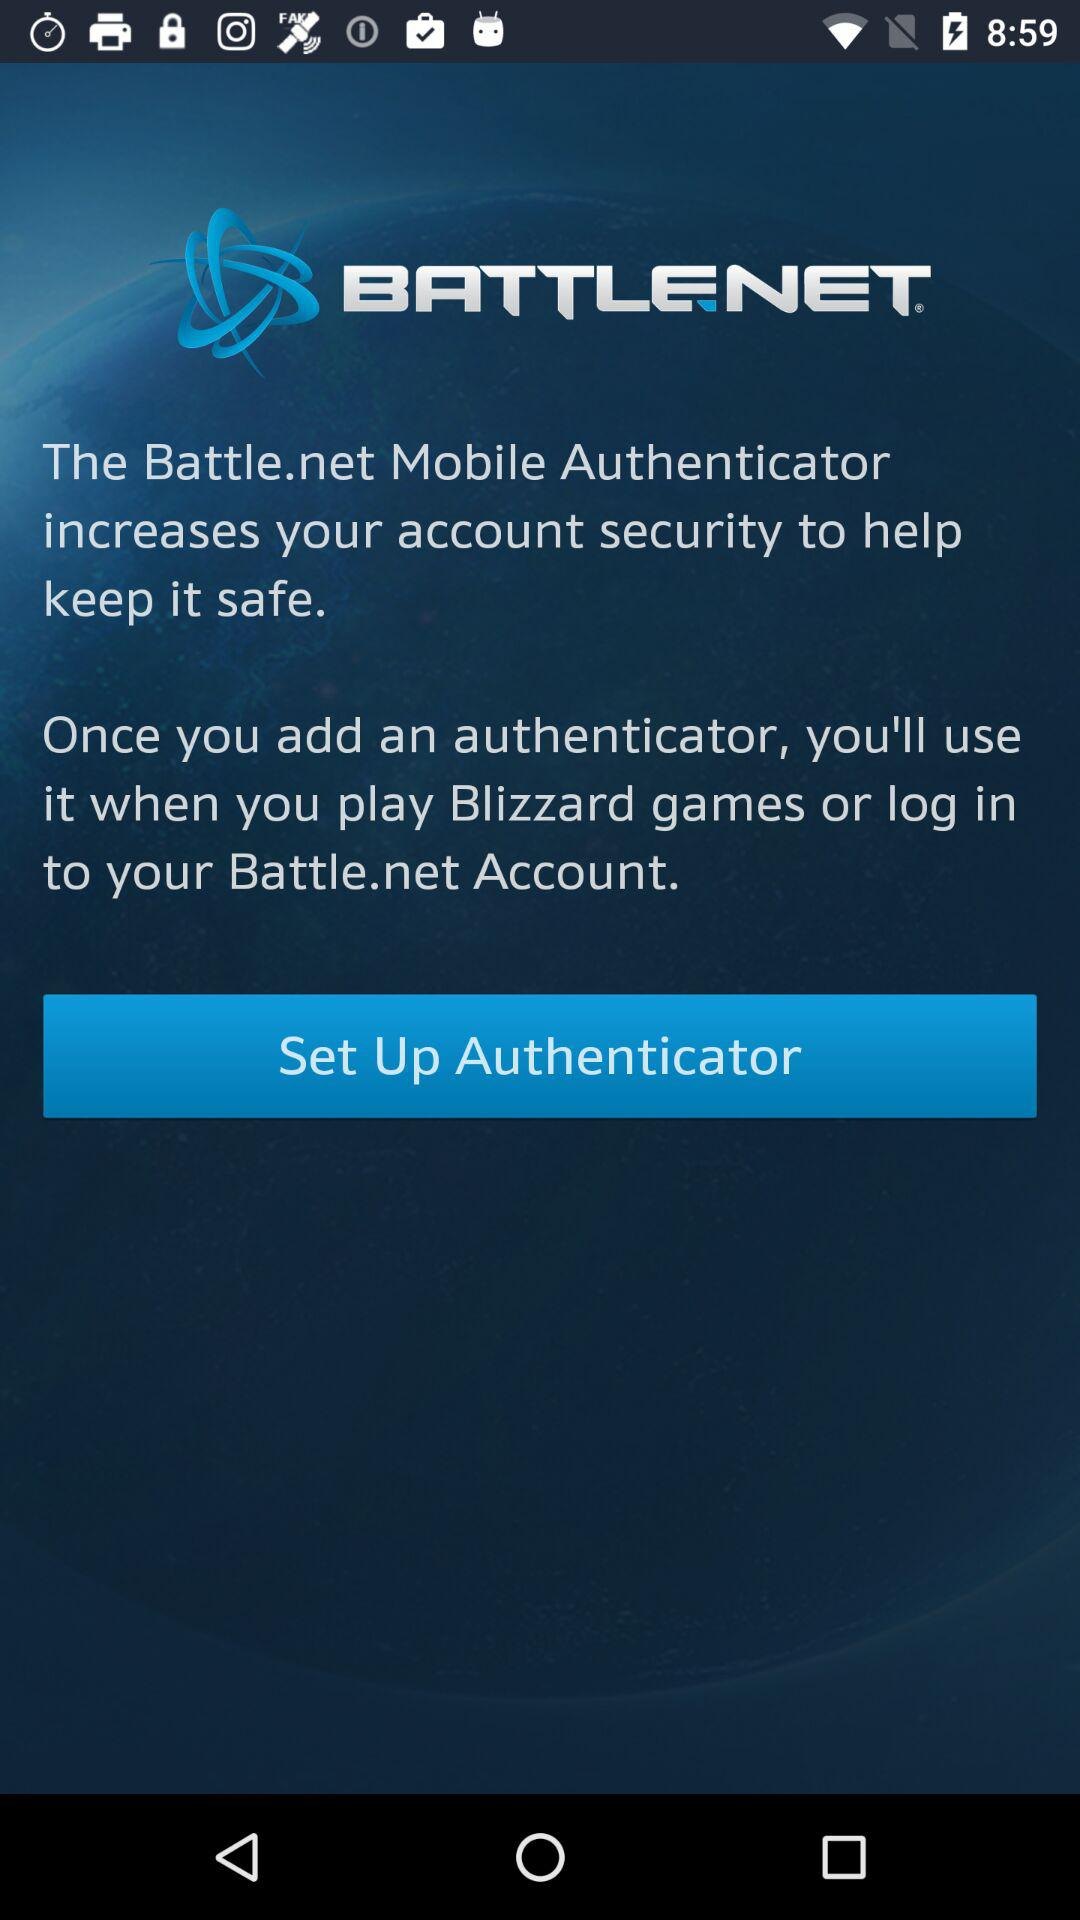What is the application name? The application name is "BATTLE.NET". 